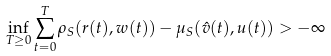<formula> <loc_0><loc_0><loc_500><loc_500>\inf _ { T \geq 0 } \sum _ { t = 0 } ^ { T } \rho _ { S } ( r ( t ) , w ( t ) ) - \mu _ { S } ( \hat { v } ( t ) , u ( t ) ) > - \infty</formula> 